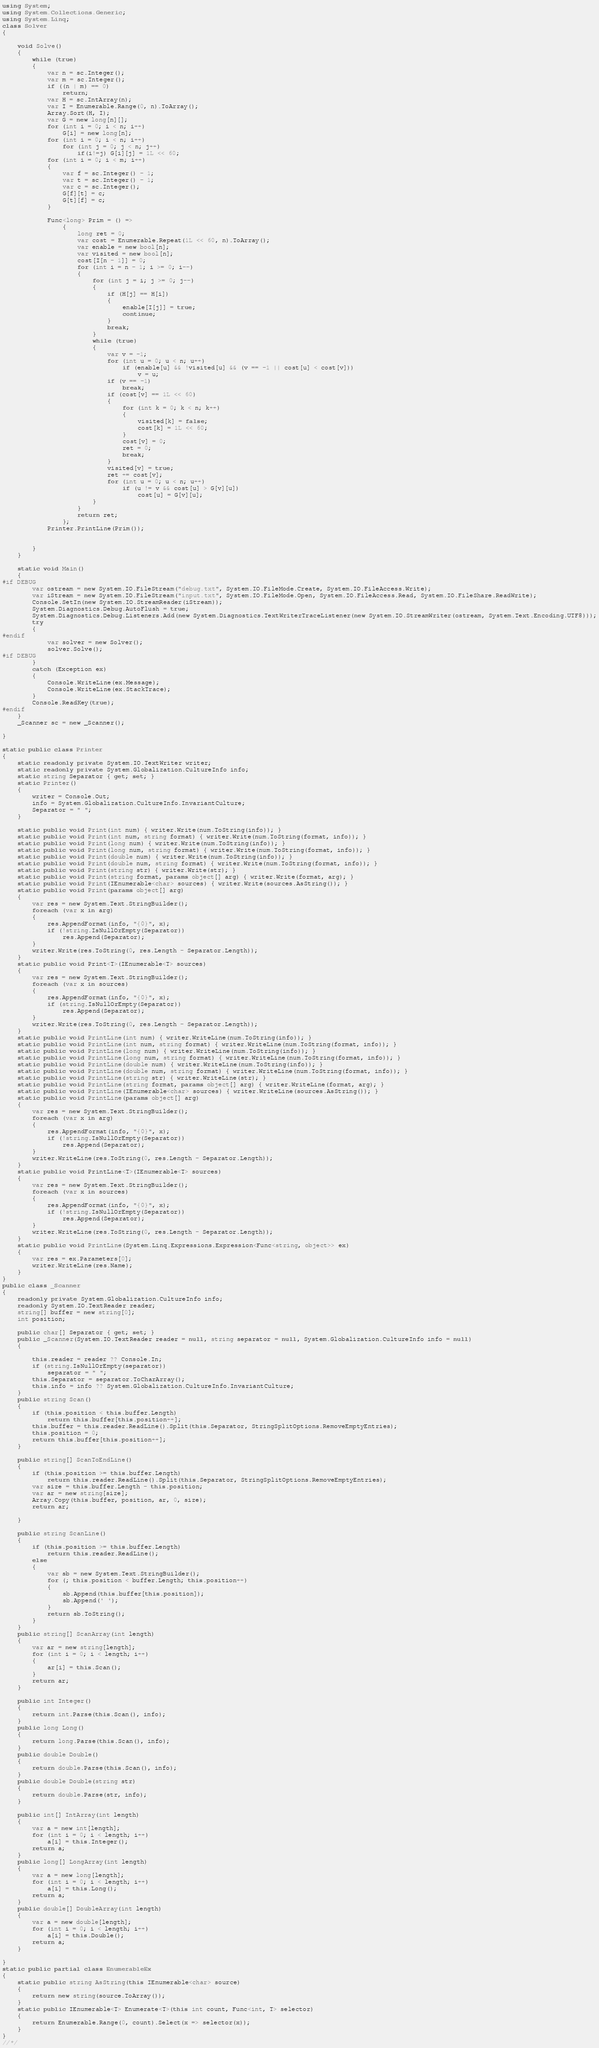Convert code to text. <code><loc_0><loc_0><loc_500><loc_500><_C#_>using System;
using System.Collections.Generic;
using System.Linq;
class Solver
{

    void Solve()
    {
        while (true)
        {
            var n = sc.Integer();
            var m = sc.Integer();
            if ((n | m) == 0)
                return;
            var H = sc.IntArray(n);
            var I = Enumerable.Range(0, n).ToArray();
            Array.Sort(H, I);
            var G = new long[n][];
            for (int i = 0; i < n; i++)
                G[i] = new long[n];
            for (int i = 0; i < n; i++)
                for (int j = 0; j < n; j++)
                    if(i!=j) G[i][j] = 1L << 60;
            for (int i = 0; i < m; i++)
            {
                var f = sc.Integer() - 1;
                var t = sc.Integer() - 1;
                var c = sc.Integer();
                G[f][t] = c;
                G[t][f] = c;
            }

            Func<long> Prim = () =>
                {
                    long ret = 0;
                    var cost = Enumerable.Repeat(1L << 60, n).ToArray();
                    var enable = new bool[n];
                    var visited = new bool[n];
                    cost[I[n - 1]] = 0;
                    for (int i = n - 1; i >= 0; i--)
                    {
                        for (int j = i; j >= 0; j--)
                        {
                            if (H[j] == H[i])
                            {
                                enable[I[j]] = true;
                                continue;
                            }
                            break;
                        }
                        while (true)
                        {
                            var v = -1;
                            for (int u = 0; u < n; u++)
                                if (enable[u] && !visited[u] && (v == -1 || cost[u] < cost[v]))
                                    v = u;
                            if (v == -1)
                                break;
                            if (cost[v] == 1L << 60)
                            {
                                for (int k = 0; k < n; k++)
                                {
                                    visited[k] = false;
                                    cost[k] = 1L << 60;
                                }
                                cost[v] = 0;
                                ret = 0;
                                break;
                            }
                            visited[v] = true;
                            ret += cost[v];
                            for (int u = 0; u < n; u++)
                                if (u != v && cost[u] > G[v][u])
                                    cost[u] = G[v][u];
                        }
                    }
                    return ret;
                };
            Printer.PrintLine(Prim());


        }
    }

    static void Main()
    {
#if DEBUG
        var ostream = new System.IO.FileStream("debug.txt", System.IO.FileMode.Create, System.IO.FileAccess.Write);
        var iStream = new System.IO.FileStream("input.txt", System.IO.FileMode.Open, System.IO.FileAccess.Read, System.IO.FileShare.ReadWrite);
        Console.SetIn(new System.IO.StreamReader(iStream));
        System.Diagnostics.Debug.AutoFlush = true;
        System.Diagnostics.Debug.Listeners.Add(new System.Diagnostics.TextWriterTraceListener(new System.IO.StreamWriter(ostream, System.Text.Encoding.UTF8)));
        try
        {
#endif
            var solver = new Solver();
            solver.Solve();
#if DEBUG
        }
        catch (Exception ex)
        {
            Console.WriteLine(ex.Message);
            Console.WriteLine(ex.StackTrace);
        }
        Console.ReadKey(true);
#endif
    }
    _Scanner sc = new _Scanner();

}

static public class Printer
{
    static readonly private System.IO.TextWriter writer;
    static readonly private System.Globalization.CultureInfo info;
    static string Separator { get; set; }
    static Printer()
    {
        writer = Console.Out;
        info = System.Globalization.CultureInfo.InvariantCulture;
        Separator = " ";
    }

    static public void Print(int num) { writer.Write(num.ToString(info)); }
    static public void Print(int num, string format) { writer.Write(num.ToString(format, info)); }
    static public void Print(long num) { writer.Write(num.ToString(info)); }
    static public void Print(long num, string format) { writer.Write(num.ToString(format, info)); }
    static public void Print(double num) { writer.Write(num.ToString(info)); }
    static public void Print(double num, string format) { writer.Write(num.ToString(format, info)); }
    static public void Print(string str) { writer.Write(str); }
    static public void Print(string format, params object[] arg) { writer.Write(format, arg); }
    static public void Print(IEnumerable<char> sources) { writer.Write(sources.AsString()); }
    static public void Print(params object[] arg)
    {
        var res = new System.Text.StringBuilder();
        foreach (var x in arg)
        {
            res.AppendFormat(info, "{0}", x);
            if (!string.IsNullOrEmpty(Separator))
                res.Append(Separator);
        }
        writer.Write(res.ToString(0, res.Length - Separator.Length));
    }
    static public void Print<T>(IEnumerable<T> sources)
    {
        var res = new System.Text.StringBuilder();
        foreach (var x in sources)
        {
            res.AppendFormat(info, "{0}", x);
            if (string.IsNullOrEmpty(Separator))
                res.Append(Separator);
        }
        writer.Write(res.ToString(0, res.Length - Separator.Length));
    }
    static public void PrintLine(int num) { writer.WriteLine(num.ToString(info)); }
    static public void PrintLine(int num, string format) { writer.WriteLine(num.ToString(format, info)); }
    static public void PrintLine(long num) { writer.WriteLine(num.ToString(info)); }
    static public void PrintLine(long num, string format) { writer.WriteLine(num.ToString(format, info)); }
    static public void PrintLine(double num) { writer.WriteLine(num.ToString(info)); }
    static public void PrintLine(double num, string format) { writer.WriteLine(num.ToString(format, info)); }
    static public void PrintLine(string str) { writer.WriteLine(str); }
    static public void PrintLine(string format, params object[] arg) { writer.WriteLine(format, arg); }
    static public void PrintLine(IEnumerable<char> sources) { writer.WriteLine(sources.AsString()); }
    static public void PrintLine(params object[] arg)
    {
        var res = new System.Text.StringBuilder();
        foreach (var x in arg)
        {
            res.AppendFormat(info, "{0}", x);
            if (!string.IsNullOrEmpty(Separator))
                res.Append(Separator);
        }
        writer.WriteLine(res.ToString(0, res.Length - Separator.Length));
    }
    static public void PrintLine<T>(IEnumerable<T> sources)
    {
        var res = new System.Text.StringBuilder();
        foreach (var x in sources)
        {
            res.AppendFormat(info, "{0}", x);
            if (!string.IsNullOrEmpty(Separator))
                res.Append(Separator);
        }
        writer.WriteLine(res.ToString(0, res.Length - Separator.Length));
    }
    static public void PrintLine(System.Linq.Expressions.Expression<Func<string, object>> ex)
    {
        var res = ex.Parameters[0];
        writer.WriteLine(res.Name);
    }
}
public class _Scanner
{
    readonly private System.Globalization.CultureInfo info;
    readonly System.IO.TextReader reader;
    string[] buffer = new string[0];
    int position;

    public char[] Separator { get; set; }
    public _Scanner(System.IO.TextReader reader = null, string separator = null, System.Globalization.CultureInfo info = null)
    {

        this.reader = reader ?? Console.In;
        if (string.IsNullOrEmpty(separator))
            separator = " ";
        this.Separator = separator.ToCharArray();
        this.info = info ?? System.Globalization.CultureInfo.InvariantCulture;
    }
    public string Scan()
    {
        if (this.position < this.buffer.Length)
            return this.buffer[this.position++];
        this.buffer = this.reader.ReadLine().Split(this.Separator, StringSplitOptions.RemoveEmptyEntries);
        this.position = 0;
        return this.buffer[this.position++];
    }

    public string[] ScanToEndLine()
    {
        if (this.position >= this.buffer.Length)
            return this.reader.ReadLine().Split(this.Separator, StringSplitOptions.RemoveEmptyEntries);
        var size = this.buffer.Length - this.position;
        var ar = new string[size];
        Array.Copy(this.buffer, position, ar, 0, size);
        return ar;

    }

    public string ScanLine()
    {
        if (this.position >= this.buffer.Length)
            return this.reader.ReadLine();
        else
        {
            var sb = new System.Text.StringBuilder();
            for (; this.position < buffer.Length; this.position++)
            {
                sb.Append(this.buffer[this.position]);
                sb.Append(' ');
            }
            return sb.ToString();
        }
    }
    public string[] ScanArray(int length)
    {
        var ar = new string[length];
        for (int i = 0; i < length; i++)
        {
            ar[i] = this.Scan();
        }
        return ar;
    }

    public int Integer()
    {
        return int.Parse(this.Scan(), info);
    }
    public long Long()
    {
        return long.Parse(this.Scan(), info);
    }
    public double Double()
    {
        return double.Parse(this.Scan(), info);
    }
    public double Double(string str)
    {
        return double.Parse(str, info);
    }

    public int[] IntArray(int length)
    {
        var a = new int[length];
        for (int i = 0; i < length; i++)
            a[i] = this.Integer();
        return a;
    }
    public long[] LongArray(int length)
    {
        var a = new long[length];
        for (int i = 0; i < length; i++)
            a[i] = this.Long();
        return a;
    }
    public double[] DoubleArray(int length)
    {
        var a = new double[length];
        for (int i = 0; i < length; i++)
            a[i] = this.Double();
        return a;
    }

}
static public partial class EnumerableEx
{
    static public string AsString(this IEnumerable<char> source)
    {
        return new string(source.ToArray());
    }
    static public IEnumerable<T> Enumerate<T>(this int count, Func<int, T> selector)
    {
        return Enumerable.Range(0, count).Select(x => selector(x));
    }
}
//*/
</code> 